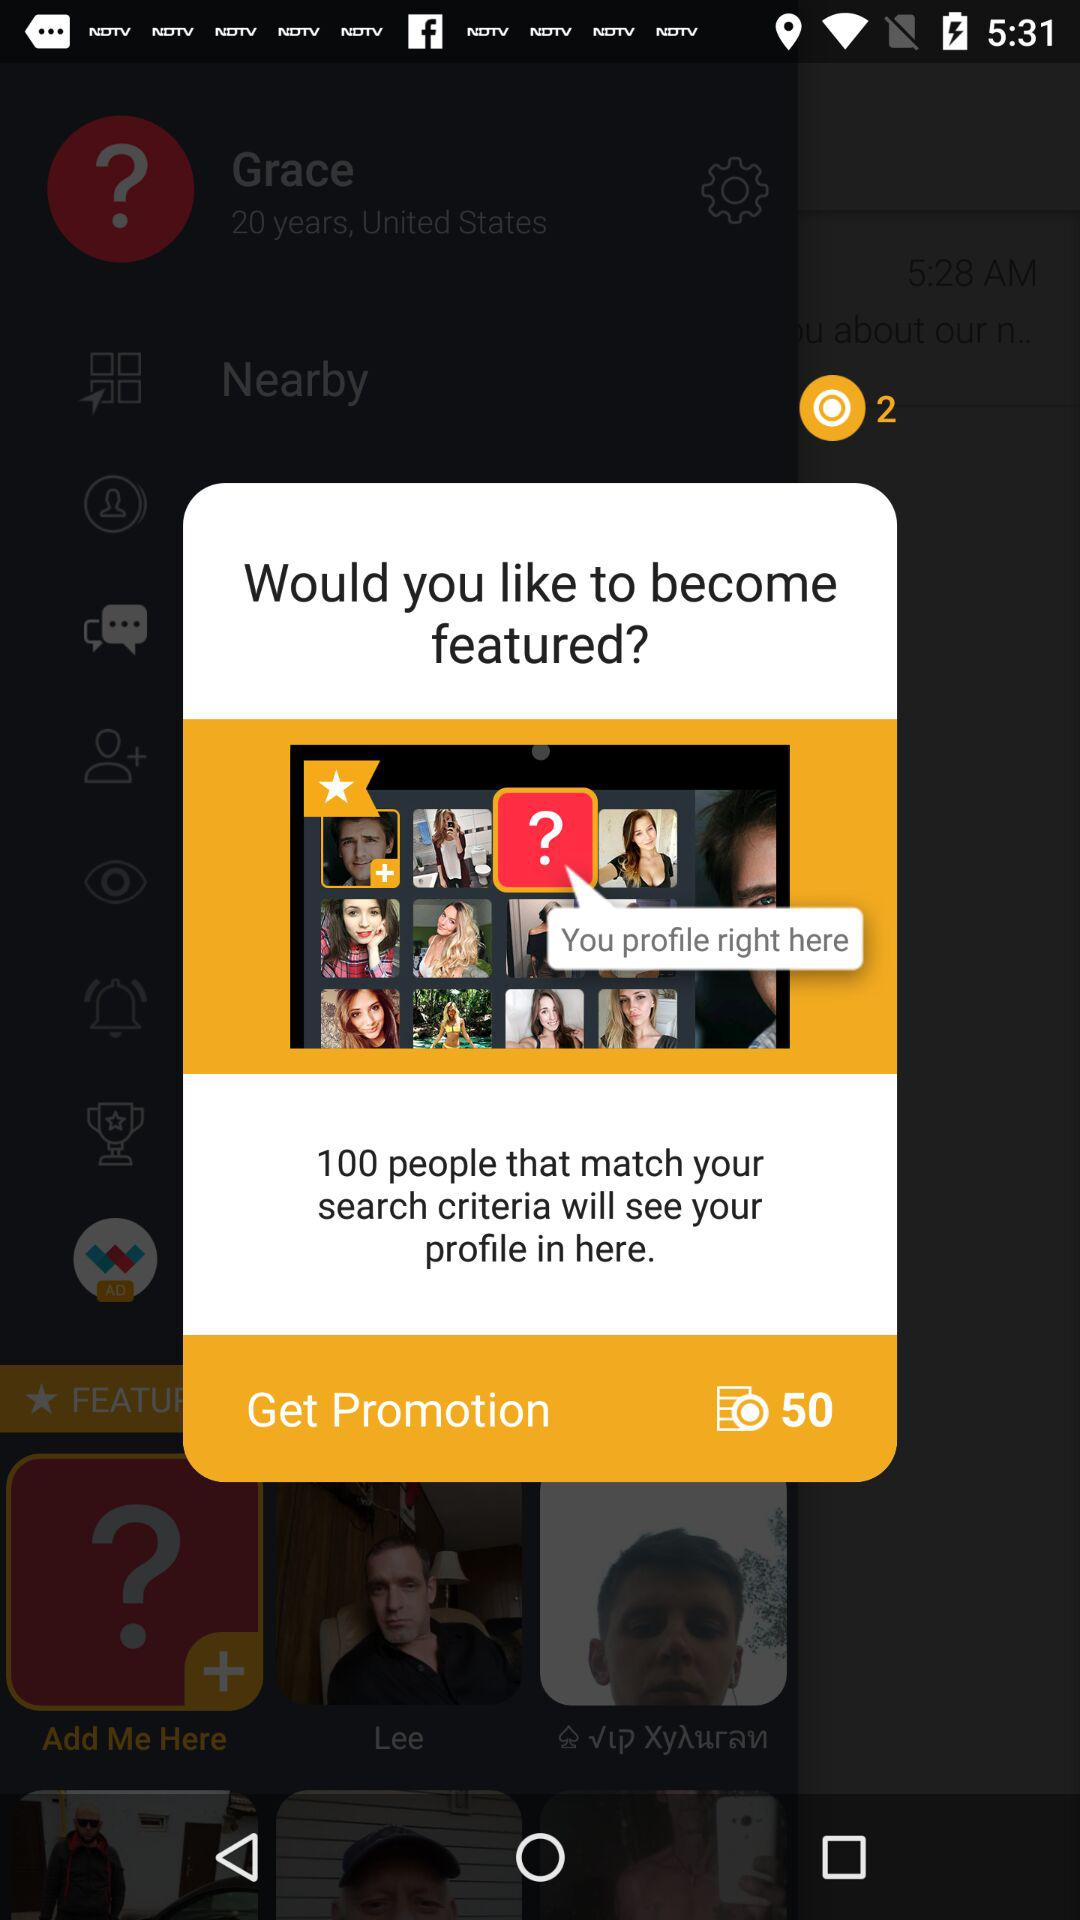How many people will see your profile if you become featured? The specific number of people who will see your profile when featured depends on the platform's user base and algorithms. Being featured usually implies higher visibility and can significantly increase the number of people who view your profile. 